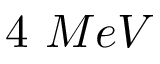Convert formula to latex. <formula><loc_0><loc_0><loc_500><loc_500>4 M e V</formula> 